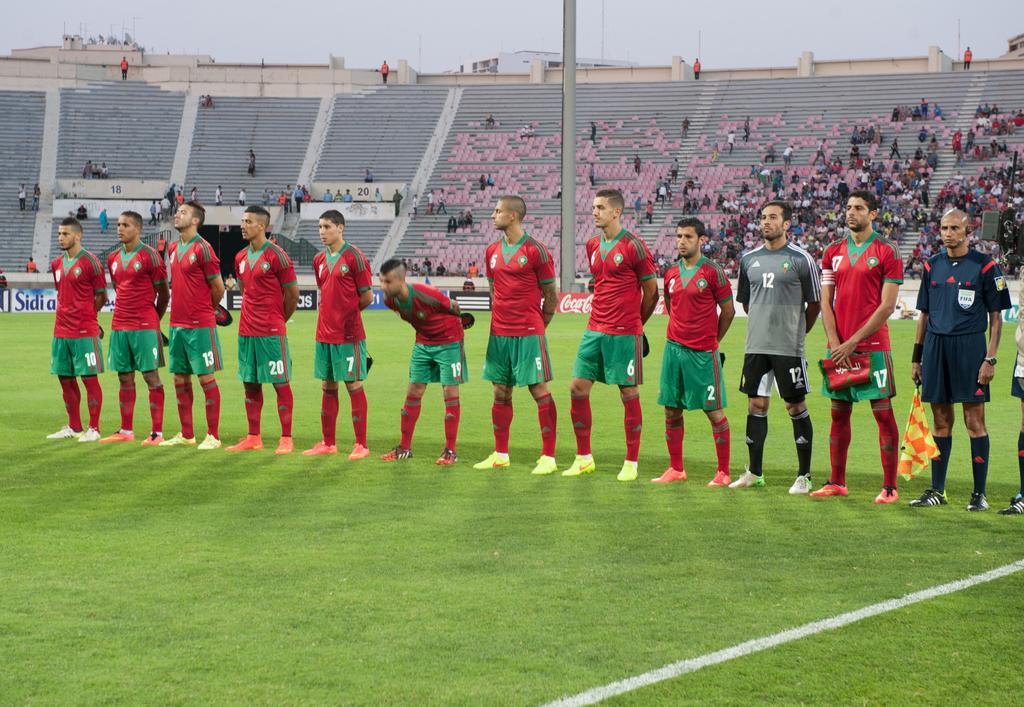In one or two sentences, can you explain what this image depicts? In this image we can see a group of people standing on the ground. One person is holding a flag in his hand. In the background, we can see a pole, staircase, group of audience and the sky. 